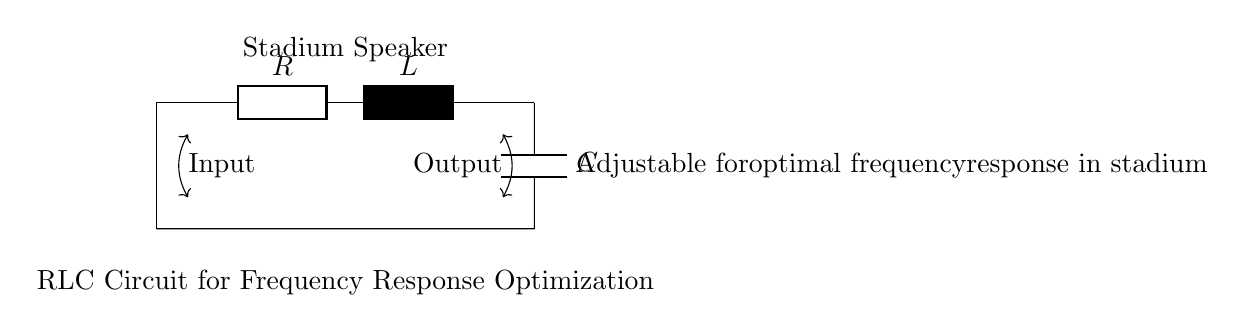what are the components in the circuit? The circuit contains a resistor, an inductor, and a capacitor, as labeled in the diagram with their respective symbols.
Answer: resistor, inductor, capacitor what is the purpose of the RLC circuit in this context? The purpose of the RLC circuit is to optimize the frequency response for a stadium sound system, allowing for better sound quality and clarity across different frequencies.
Answer: frequency response optimization how is the stadium speaker positioned in relation to the circuit? The stadium speaker is positioned at the output of the circuit, indicated by the labeling that shows it is directly connected to the circuits output.
Answer: at the output what is the type of circuit shown? The circuit is a resonant circuit, specifically a series RLC circuit, which uses a resistor, an inductor, and a capacitor in sequence to manage frequency response.
Answer: series RLC how can the RLC circuit be adjusted for optimal performance? The circuit components, R, L, and C, can be adjusted (changed in value) to reach the desired matched frequency for optimal performance in the stadium.
Answer: adjust R, L, C values what does the input to the circuit represent? The input represents the signal feeding into the RLC circuit, which could be an audio signal from a sound system.
Answer: audio signal how does the output indicate optimal frequency response? The output reflects the processed audio signal after passing through the RLC circuit, indicating that adjustments have been made for optimal amplification at certain frequencies.
Answer: processed audio signal 